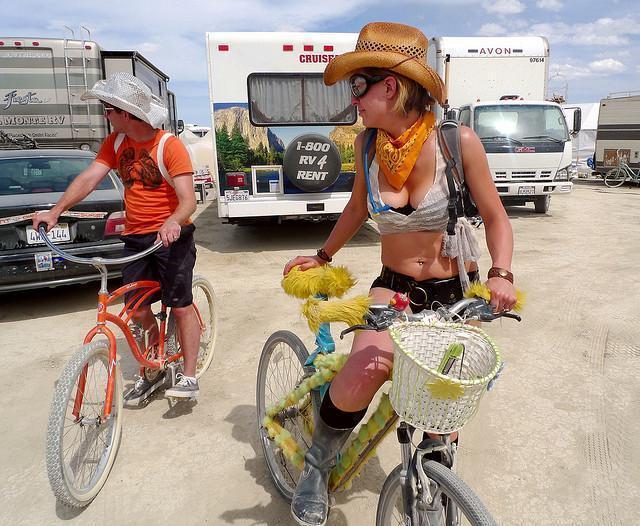How many bicycles are in the photo?
Give a very brief answer. 2. How many trucks are there?
Give a very brief answer. 4. How many people are there?
Give a very brief answer. 2. 